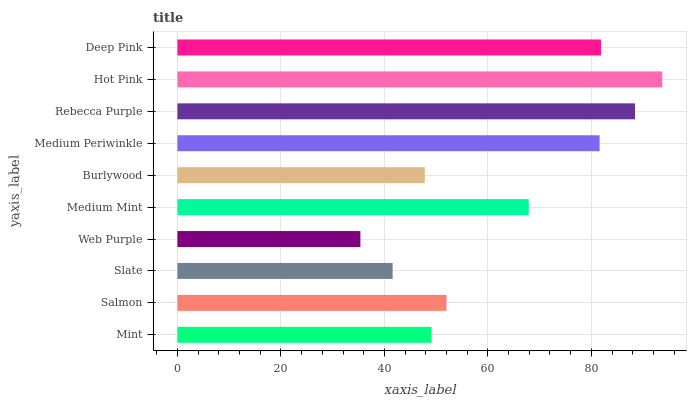Is Web Purple the minimum?
Answer yes or no. Yes. Is Hot Pink the maximum?
Answer yes or no. Yes. Is Salmon the minimum?
Answer yes or no. No. Is Salmon the maximum?
Answer yes or no. No. Is Salmon greater than Mint?
Answer yes or no. Yes. Is Mint less than Salmon?
Answer yes or no. Yes. Is Mint greater than Salmon?
Answer yes or no. No. Is Salmon less than Mint?
Answer yes or no. No. Is Medium Mint the high median?
Answer yes or no. Yes. Is Salmon the low median?
Answer yes or no. Yes. Is Hot Pink the high median?
Answer yes or no. No. Is Medium Periwinkle the low median?
Answer yes or no. No. 